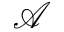<formula> <loc_0><loc_0><loc_500><loc_500>\mathcal { A }</formula> 